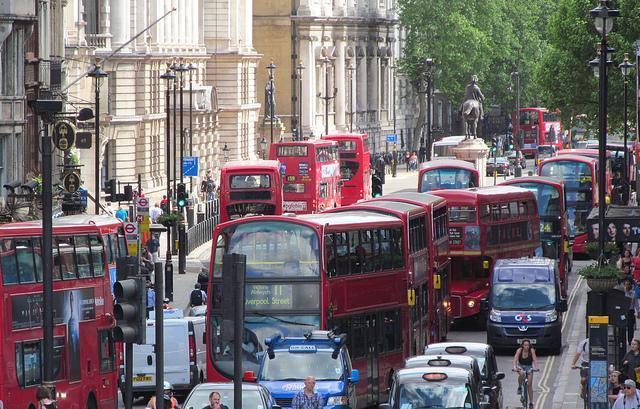How many non-red buses are in the street?
Give a very brief answer. 0. How many buses are there?
Give a very brief answer. 9. How many cars are in the photo?
Give a very brief answer. 3. How many kites look like octopi?
Give a very brief answer. 0. 